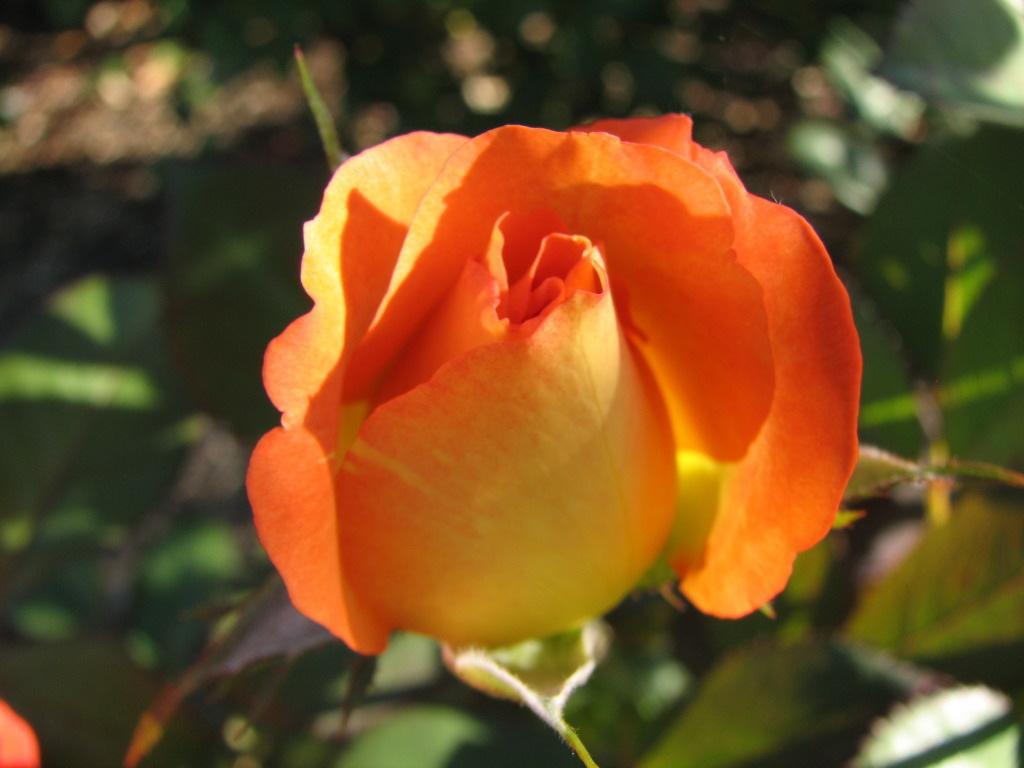How would you summarize this image in a sentence or two? In this image I see a flower which is of orange and yellow in color and it is totally blurred in the background and I see the leaves. 